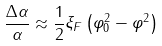<formula> <loc_0><loc_0><loc_500><loc_500>\frac { \Delta \alpha } { \alpha } \approx \frac { 1 } { 2 } \xi _ { F } \left ( \varphi _ { 0 } ^ { 2 } - \varphi ^ { 2 } \right )</formula> 